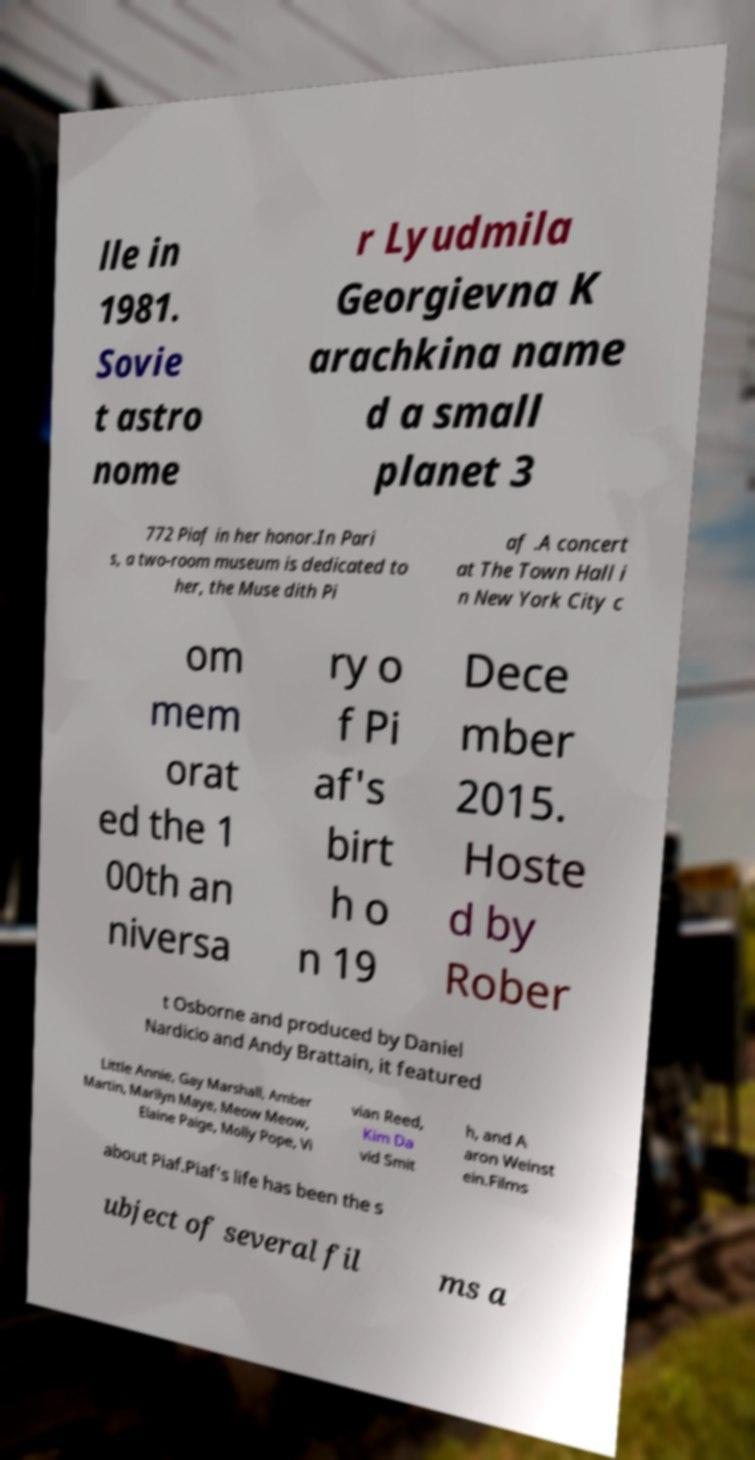Can you accurately transcribe the text from the provided image for me? lle in 1981. Sovie t astro nome r Lyudmila Georgievna K arachkina name d a small planet 3 772 Piaf in her honor.In Pari s, a two-room museum is dedicated to her, the Muse dith Pi af .A concert at The Town Hall i n New York City c om mem orat ed the 1 00th an niversa ry o f Pi af's birt h o n 19 Dece mber 2015. Hoste d by Rober t Osborne and produced by Daniel Nardicio and Andy Brattain, it featured Little Annie, Gay Marshall, Amber Martin, Marilyn Maye, Meow Meow, Elaine Paige, Molly Pope, Vi vian Reed, Kim Da vid Smit h, and A aron Weinst ein.Films about Piaf.Piaf's life has been the s ubject of several fil ms a 